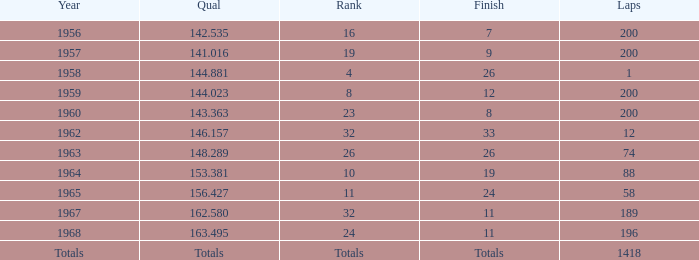Which qual also possesses a final tally of 9? 141.016. 